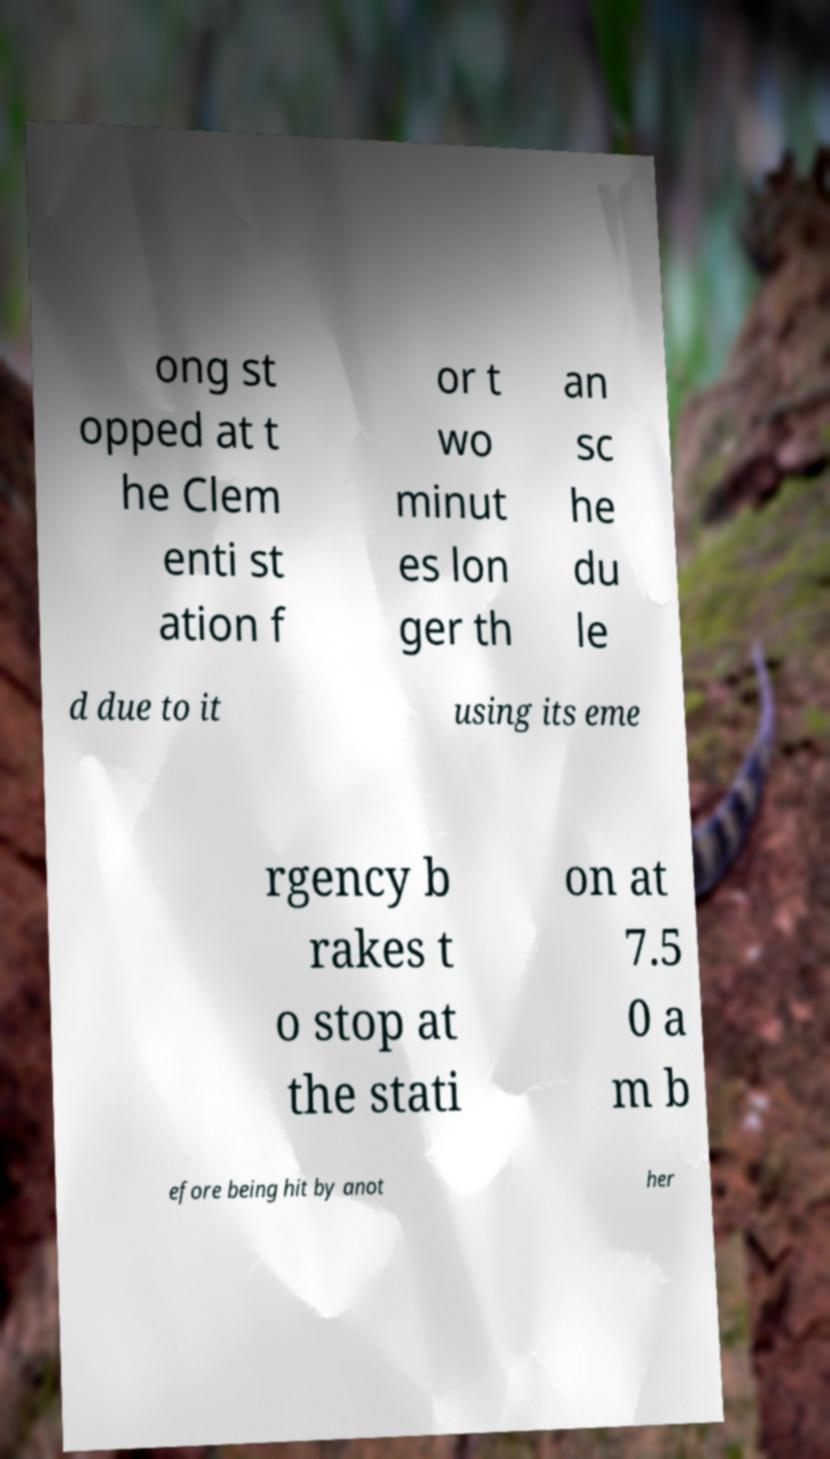I need the written content from this picture converted into text. Can you do that? ong st opped at t he Clem enti st ation f or t wo minut es lon ger th an sc he du le d due to it using its eme rgency b rakes t o stop at the stati on at 7.5 0 a m b efore being hit by anot her 